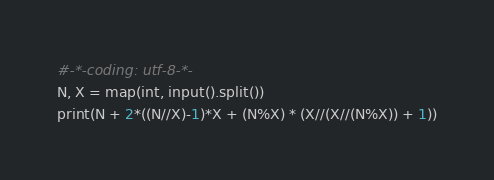<code> <loc_0><loc_0><loc_500><loc_500><_Python_>#-*-coding: utf-8-*-
N, X = map(int, input().split())
print(N + 2*((N//X)-1)*X + (N%X) * (X//(X//(N%X)) + 1))</code> 